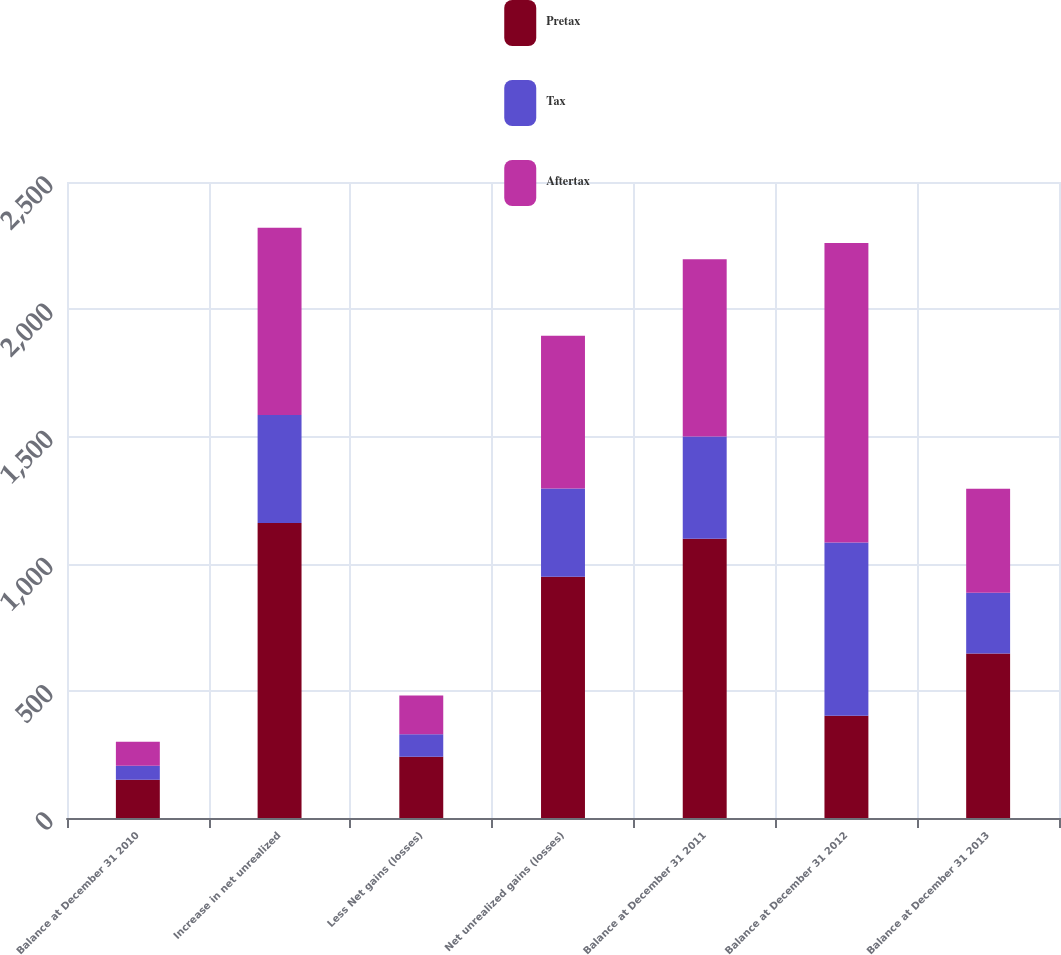Convert chart to OTSL. <chart><loc_0><loc_0><loc_500><loc_500><stacked_bar_chart><ecel><fcel>Balance at December 31 2010<fcel>Increase in net unrealized<fcel>Less Net gains (losses)<fcel>Net unrealized gains (losses)<fcel>Balance at December 31 2011<fcel>Balance at December 31 2012<fcel>Balance at December 31 2013<nl><fcel>Pretax<fcel>150<fcel>1160<fcel>241<fcel>948<fcel>1098<fcel>402<fcel>647<nl><fcel>Tax<fcel>55<fcel>424<fcel>88<fcel>347<fcel>402<fcel>681<fcel>238<nl><fcel>Aftertax<fcel>95<fcel>736<fcel>153<fcel>601<fcel>696<fcel>1177<fcel>409<nl></chart> 